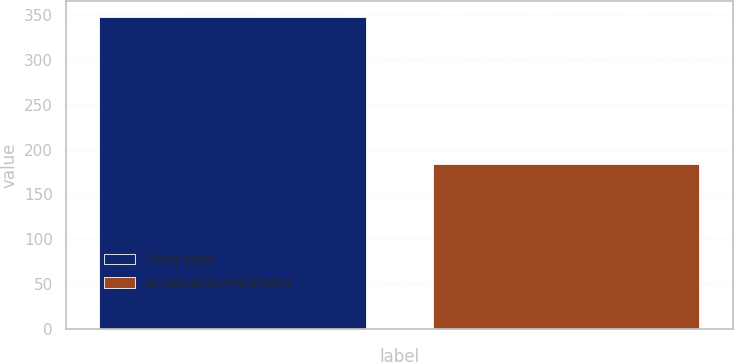Convert chart to OTSL. <chart><loc_0><loc_0><loc_500><loc_500><bar_chart><fcel>Gross asset<fcel>Accumulated amortization<nl><fcel>348<fcel>184<nl></chart> 